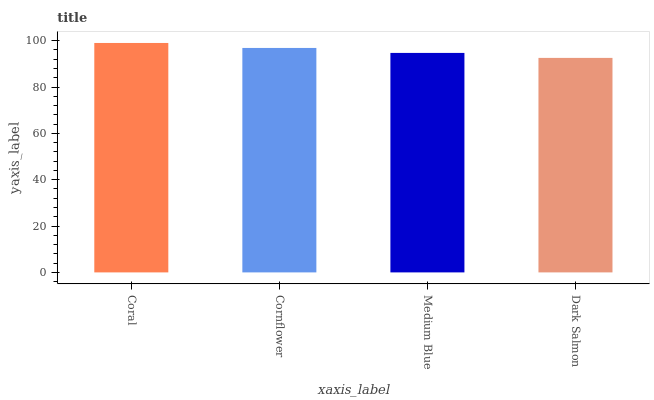Is Dark Salmon the minimum?
Answer yes or no. Yes. Is Coral the maximum?
Answer yes or no. Yes. Is Cornflower the minimum?
Answer yes or no. No. Is Cornflower the maximum?
Answer yes or no. No. Is Coral greater than Cornflower?
Answer yes or no. Yes. Is Cornflower less than Coral?
Answer yes or no. Yes. Is Cornflower greater than Coral?
Answer yes or no. No. Is Coral less than Cornflower?
Answer yes or no. No. Is Cornflower the high median?
Answer yes or no. Yes. Is Medium Blue the low median?
Answer yes or no. Yes. Is Medium Blue the high median?
Answer yes or no. No. Is Dark Salmon the low median?
Answer yes or no. No. 